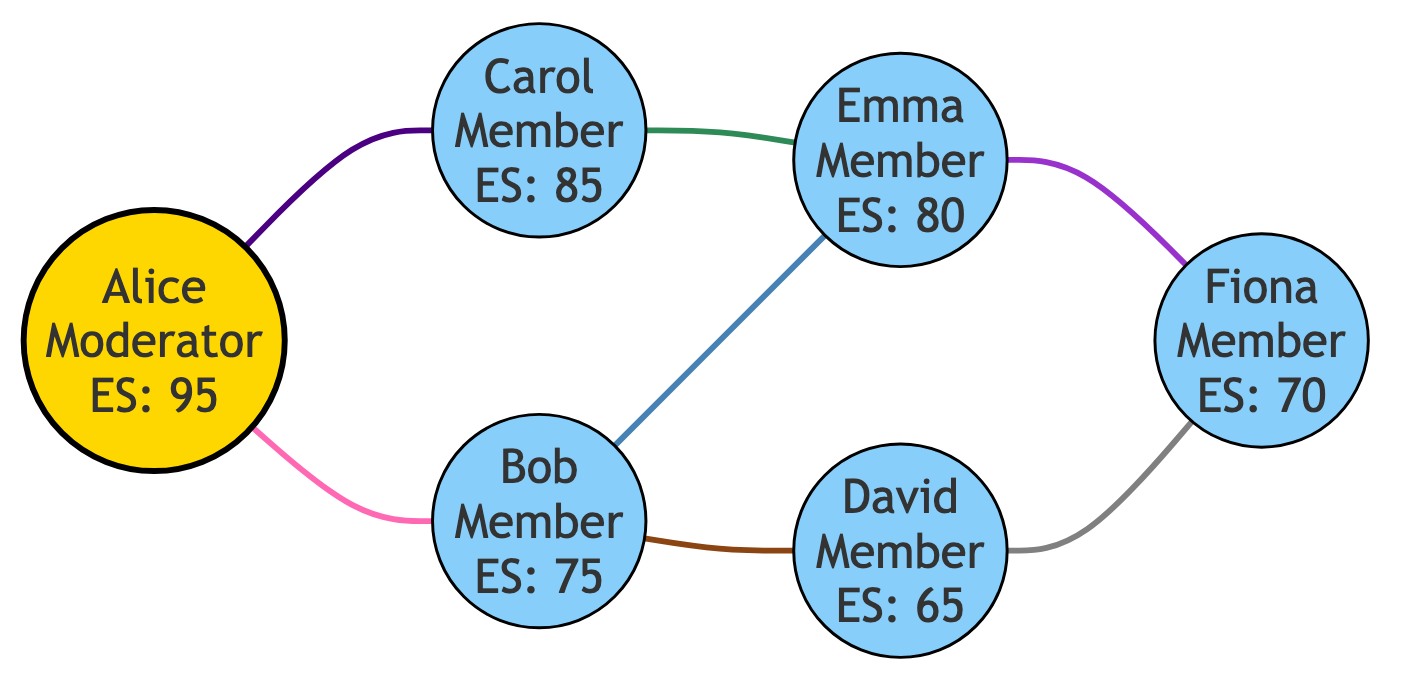What is the role of Alice in the book club? In the diagram, Alice is labeled as "Club Moderator," which can be inferred from the attributes linked to her node.
Answer: Club Moderator How many members are there in the book club? By counting the nodes labeled as members (excluding the moderator), we find there are five members: Bob, Carol, David, Emma, and Fiona.
Answer: 5 What is Carol's engagement score? The node representing Carol indicates her engagement score directly as "85." This value is extracted from the attributes in her node.
Answer: 85 Which two members share an interest in Contemporary Literature? The edge connecting Carol and Emma is labeled "Shared Interest: Contemporary Literature," indicating that they share this interest.
Answer: Carol and Emma What is the minimum engagement score among the members? By examining the engagement scores of all members (Bob: 75, Carol: 85, David: 65, Emma: 80, Fiona: 70), David has the lowest engagement score, which is 65.
Answer: 65 How many shared interests are there between Bob and other members? Bob has edges connecting him to Alice (Mystery Novels), David (Historical Fiction), Emma (Poetry), indicating a total of three shared interests with other members.
Answer: 3 Which member is connected to the most other members? By analyzing the edges, Alice is connected to two members (Bob and Carol), while Bob connects to three members (Alice, David, Emma). Hence, Bob has the highest connections.
Answer: Bob What is the shared interest between Emma and Fiona? The edge between Emma and Fiona is labeled "Shared Interest: Fantasy Novels," indicating their shared interest directly from the edge's label.
Answer: Fantasy Novels Which node has the highest engagement score? The node for Alice shows an engagement score of 95, which is higher than any other member's scores in the diagram.
Answer: 95 